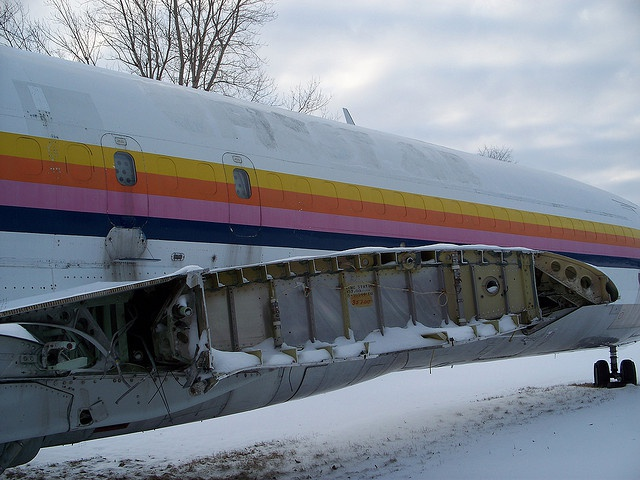Describe the objects in this image and their specific colors. I can see a airplane in darkgray, black, and gray tones in this image. 